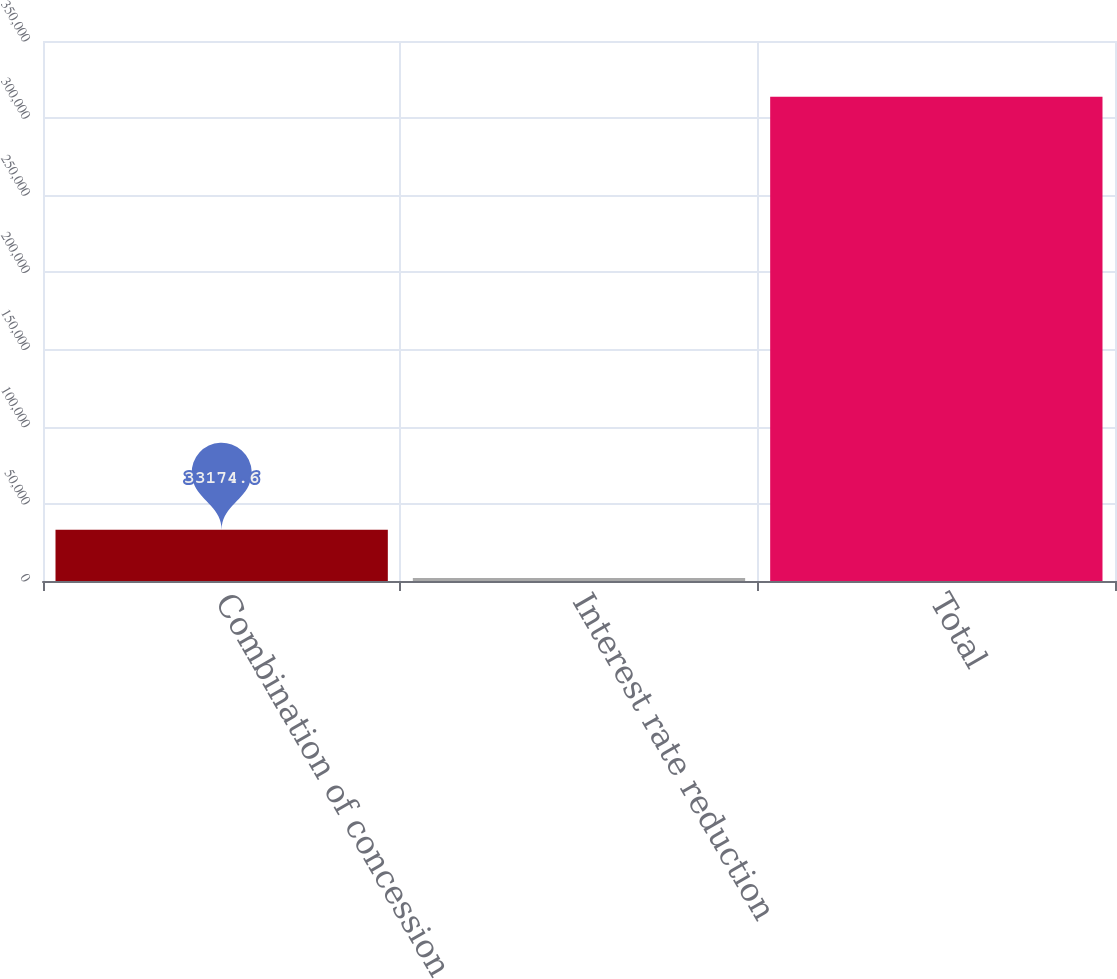Convert chart. <chart><loc_0><loc_0><loc_500><loc_500><bar_chart><fcel>Combination of concession<fcel>Interest rate reduction<fcel>Total<nl><fcel>33174.6<fcel>1991<fcel>313827<nl></chart> 